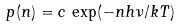Convert formula to latex. <formula><loc_0><loc_0><loc_500><loc_500>p ( n ) = c \, \exp ( - n h { \nu } / k T )</formula> 